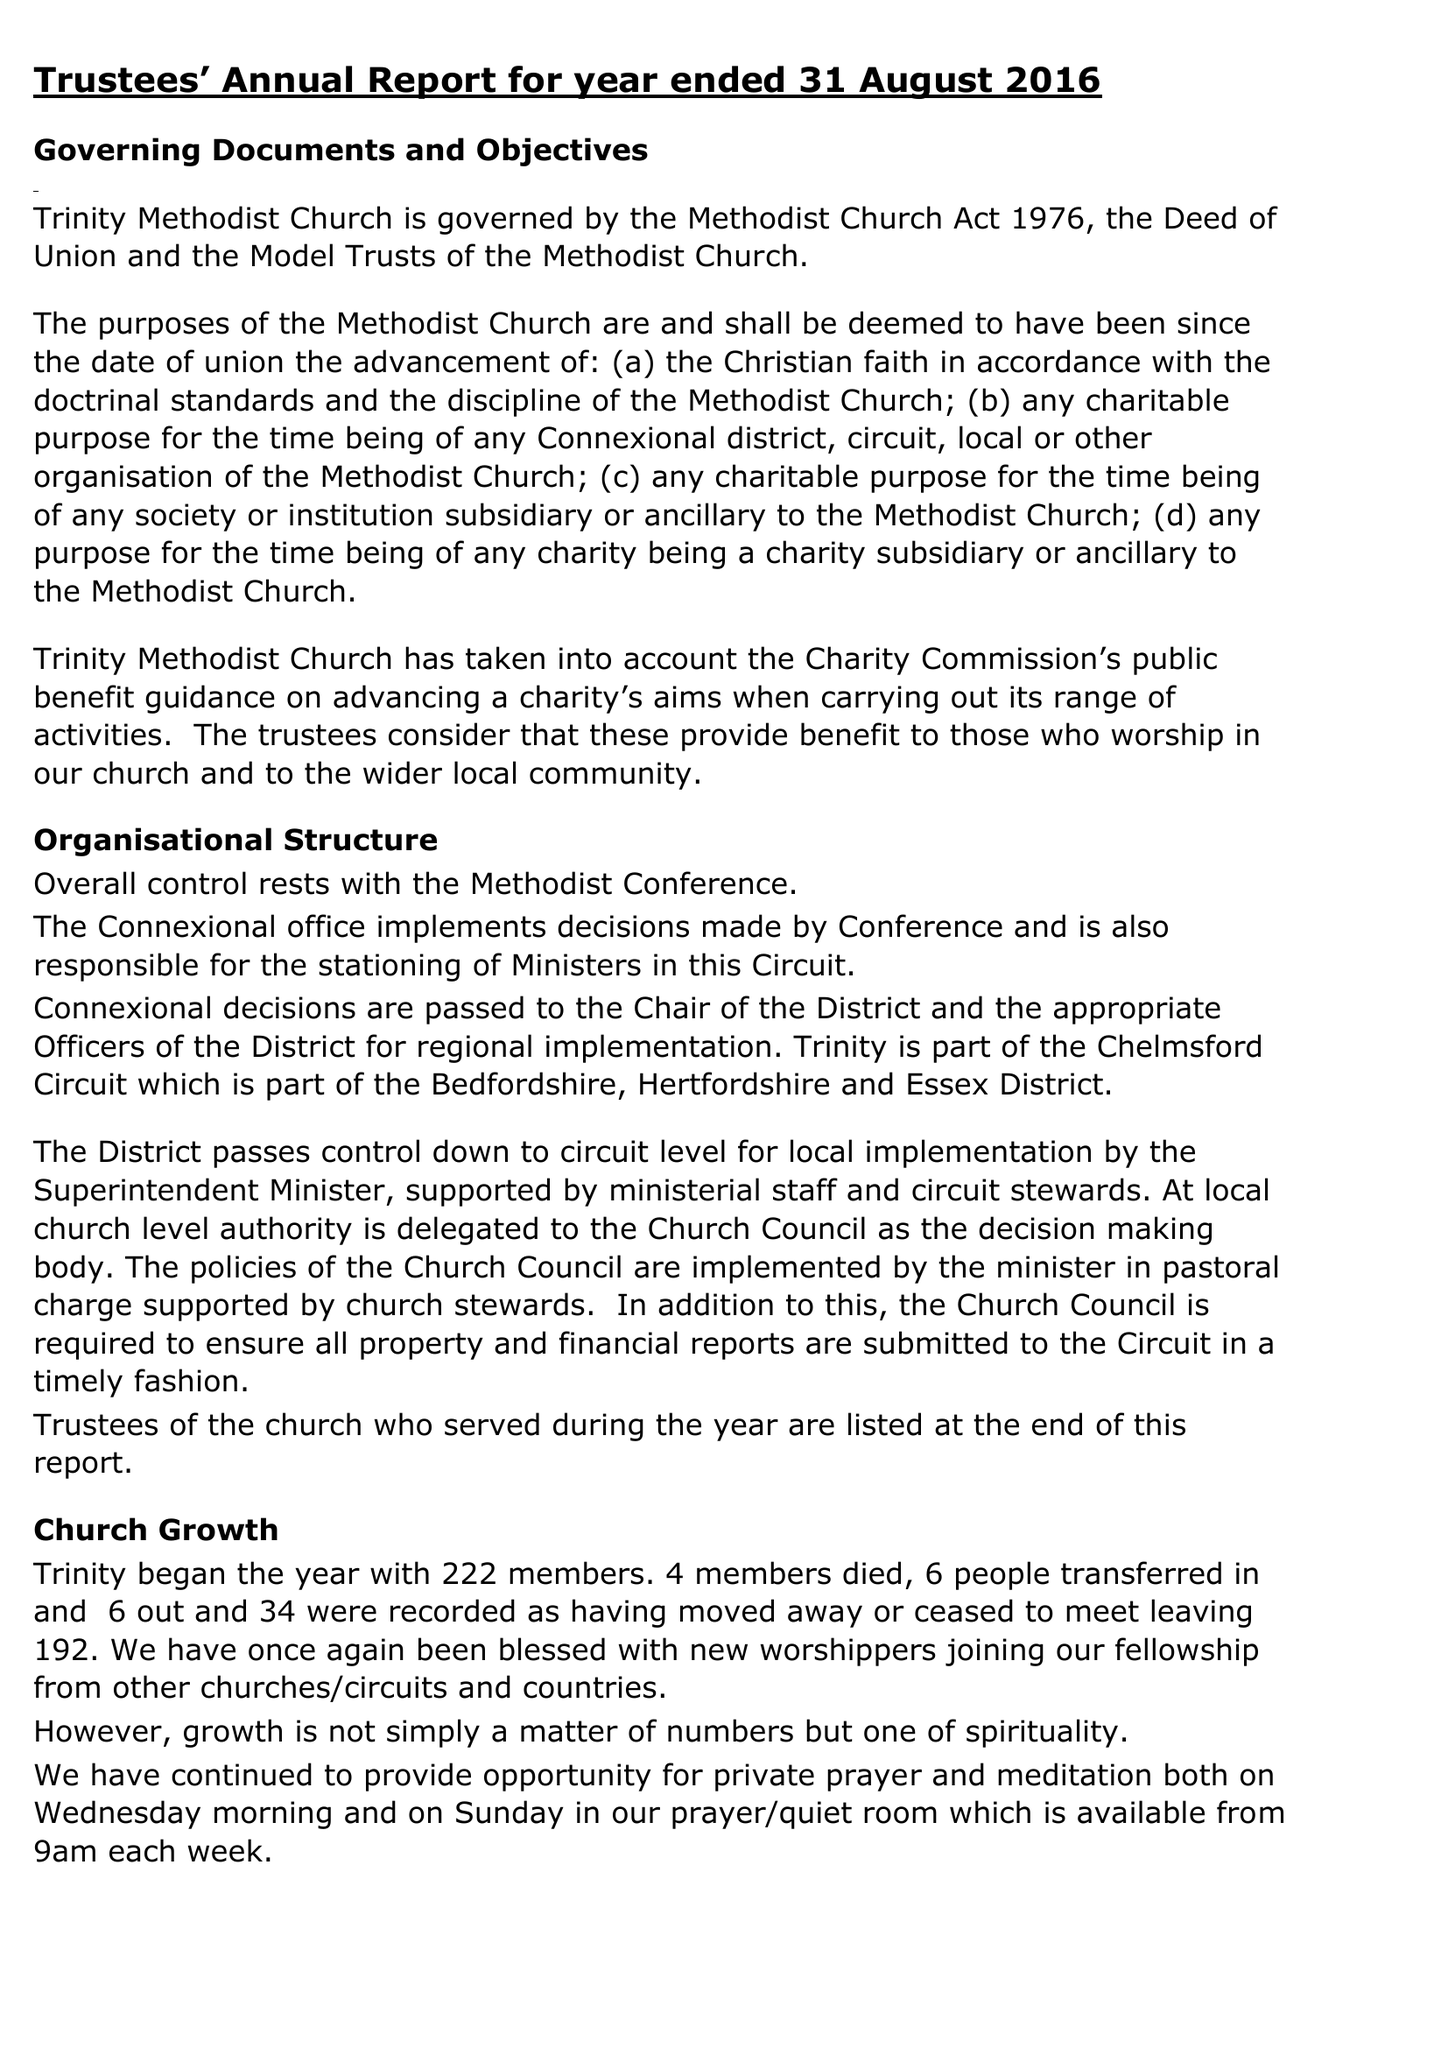What is the value for the address__street_line?
Answer the question using a single word or phrase. 30 PARK AVENUE 